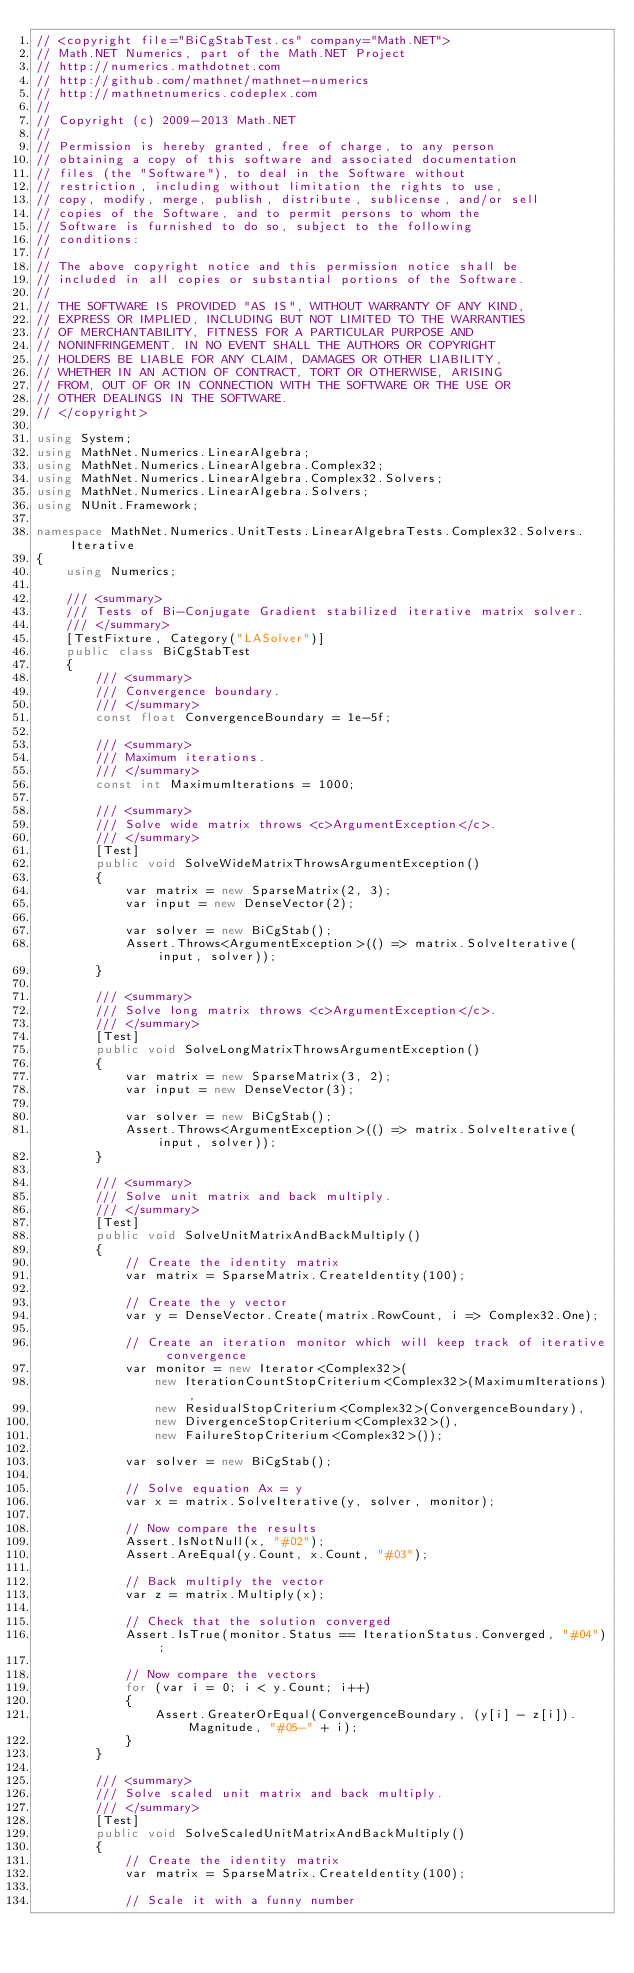Convert code to text. <code><loc_0><loc_0><loc_500><loc_500><_C#_>// <copyright file="BiCgStabTest.cs" company="Math.NET">
// Math.NET Numerics, part of the Math.NET Project
// http://numerics.mathdotnet.com
// http://github.com/mathnet/mathnet-numerics
// http://mathnetnumerics.codeplex.com
//
// Copyright (c) 2009-2013 Math.NET
//
// Permission is hereby granted, free of charge, to any person
// obtaining a copy of this software and associated documentation
// files (the "Software"), to deal in the Software without
// restriction, including without limitation the rights to use,
// copy, modify, merge, publish, distribute, sublicense, and/or sell
// copies of the Software, and to permit persons to whom the
// Software is furnished to do so, subject to the following
// conditions:
//
// The above copyright notice and this permission notice shall be
// included in all copies or substantial portions of the Software.
//
// THE SOFTWARE IS PROVIDED "AS IS", WITHOUT WARRANTY OF ANY KIND,
// EXPRESS OR IMPLIED, INCLUDING BUT NOT LIMITED TO THE WARRANTIES
// OF MERCHANTABILITY, FITNESS FOR A PARTICULAR PURPOSE AND
// NONINFRINGEMENT. IN NO EVENT SHALL THE AUTHORS OR COPYRIGHT
// HOLDERS BE LIABLE FOR ANY CLAIM, DAMAGES OR OTHER LIABILITY,
// WHETHER IN AN ACTION OF CONTRACT, TORT OR OTHERWISE, ARISING
// FROM, OUT OF OR IN CONNECTION WITH THE SOFTWARE OR THE USE OR
// OTHER DEALINGS IN THE SOFTWARE.
// </copyright>

using System;
using MathNet.Numerics.LinearAlgebra;
using MathNet.Numerics.LinearAlgebra.Complex32;
using MathNet.Numerics.LinearAlgebra.Complex32.Solvers;
using MathNet.Numerics.LinearAlgebra.Solvers;
using NUnit.Framework;

namespace MathNet.Numerics.UnitTests.LinearAlgebraTests.Complex32.Solvers.Iterative
{
    using Numerics;

    /// <summary>
    /// Tests of Bi-Conjugate Gradient stabilized iterative matrix solver.
    /// </summary>
    [TestFixture, Category("LASolver")]
    public class BiCgStabTest
    {
        /// <summary>
        /// Convergence boundary.
        /// </summary>
        const float ConvergenceBoundary = 1e-5f;

        /// <summary>
        /// Maximum iterations.
        /// </summary>
        const int MaximumIterations = 1000;

        /// <summary>
        /// Solve wide matrix throws <c>ArgumentException</c>.
        /// </summary>
        [Test]
        public void SolveWideMatrixThrowsArgumentException()
        {
            var matrix = new SparseMatrix(2, 3);
            var input = new DenseVector(2);

            var solver = new BiCgStab();
            Assert.Throws<ArgumentException>(() => matrix.SolveIterative(input, solver));
        }

        /// <summary>
        /// Solve long matrix throws <c>ArgumentException</c>.
        /// </summary>
        [Test]
        public void SolveLongMatrixThrowsArgumentException()
        {
            var matrix = new SparseMatrix(3, 2);
            var input = new DenseVector(3);

            var solver = new BiCgStab();
            Assert.Throws<ArgumentException>(() => matrix.SolveIterative(input, solver));
        }

        /// <summary>
        /// Solve unit matrix and back multiply.
        /// </summary>
        [Test]
        public void SolveUnitMatrixAndBackMultiply()
        {
            // Create the identity matrix
            var matrix = SparseMatrix.CreateIdentity(100);

            // Create the y vector
            var y = DenseVector.Create(matrix.RowCount, i => Complex32.One);

            // Create an iteration monitor which will keep track of iterative convergence
            var monitor = new Iterator<Complex32>(
                new IterationCountStopCriterium<Complex32>(MaximumIterations),
                new ResidualStopCriterium<Complex32>(ConvergenceBoundary),
                new DivergenceStopCriterium<Complex32>(),
                new FailureStopCriterium<Complex32>());

            var solver = new BiCgStab();

            // Solve equation Ax = y
            var x = matrix.SolveIterative(y, solver, monitor);

            // Now compare the results
            Assert.IsNotNull(x, "#02");
            Assert.AreEqual(y.Count, x.Count, "#03");

            // Back multiply the vector
            var z = matrix.Multiply(x);

            // Check that the solution converged
            Assert.IsTrue(monitor.Status == IterationStatus.Converged, "#04");

            // Now compare the vectors
            for (var i = 0; i < y.Count; i++)
            {
                Assert.GreaterOrEqual(ConvergenceBoundary, (y[i] - z[i]).Magnitude, "#05-" + i);
            }
        }

        /// <summary>
        /// Solve scaled unit matrix and back multiply.
        /// </summary>
        [Test]
        public void SolveScaledUnitMatrixAndBackMultiply()
        {
            // Create the identity matrix
            var matrix = SparseMatrix.CreateIdentity(100);

            // Scale it with a funny number</code> 